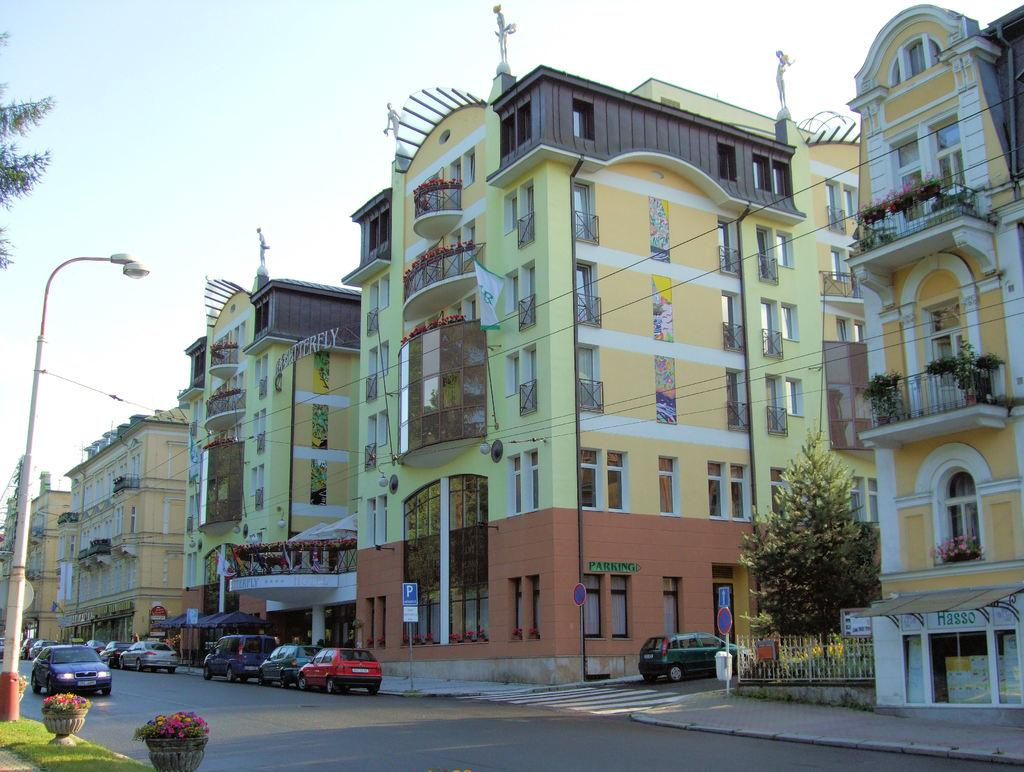What is the main subject in the center of the image? There are buildings in the center of the image. What can be seen at the bottom side of the image? There are cars at the bottom side of the image. Where are the plant pots located in the image? The plant pots are in the bottom left side of the image. What type of prose is being recited in the image? There is no indication of any prose or recitation in the image; it primarily features buildings, cars, and plant pots. 